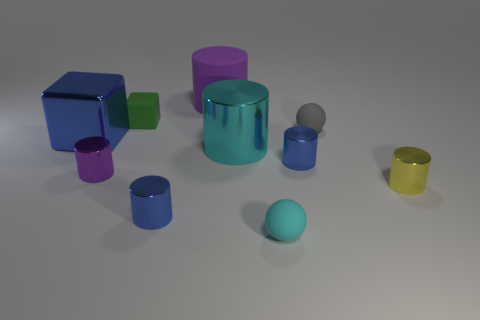Subtract all purple matte cylinders. How many cylinders are left? 5 Subtract all green blocks. How many purple cylinders are left? 2 Subtract all yellow cylinders. How many cylinders are left? 5 Subtract 4 cylinders. How many cylinders are left? 2 Add 4 yellow metal objects. How many yellow metal objects exist? 5 Subtract 0 red blocks. How many objects are left? 10 Subtract all balls. How many objects are left? 8 Subtract all yellow cylinders. Subtract all green spheres. How many cylinders are left? 5 Subtract all big green metallic blocks. Subtract all small balls. How many objects are left? 8 Add 8 big metallic cubes. How many big metallic cubes are left? 9 